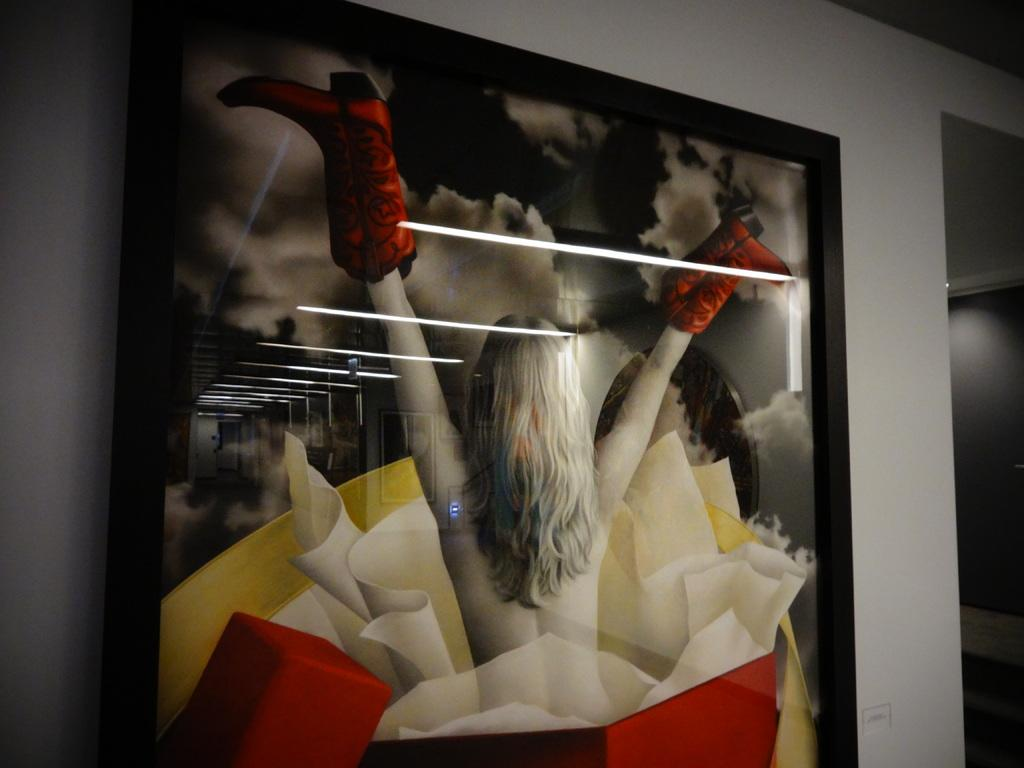What is hanging on the wall in the image? There is a photo on a wall in the image. What can be seen in the photo? The photo features a lady. What is visible on the photo due to the lighting? There are lamp reflections on the photo. What type of copper material can be seen in the image? There is no copper material present in the image. How does the lady in the photo twist her head? The lady in the photo is not twisting her head, as it is a still image. 